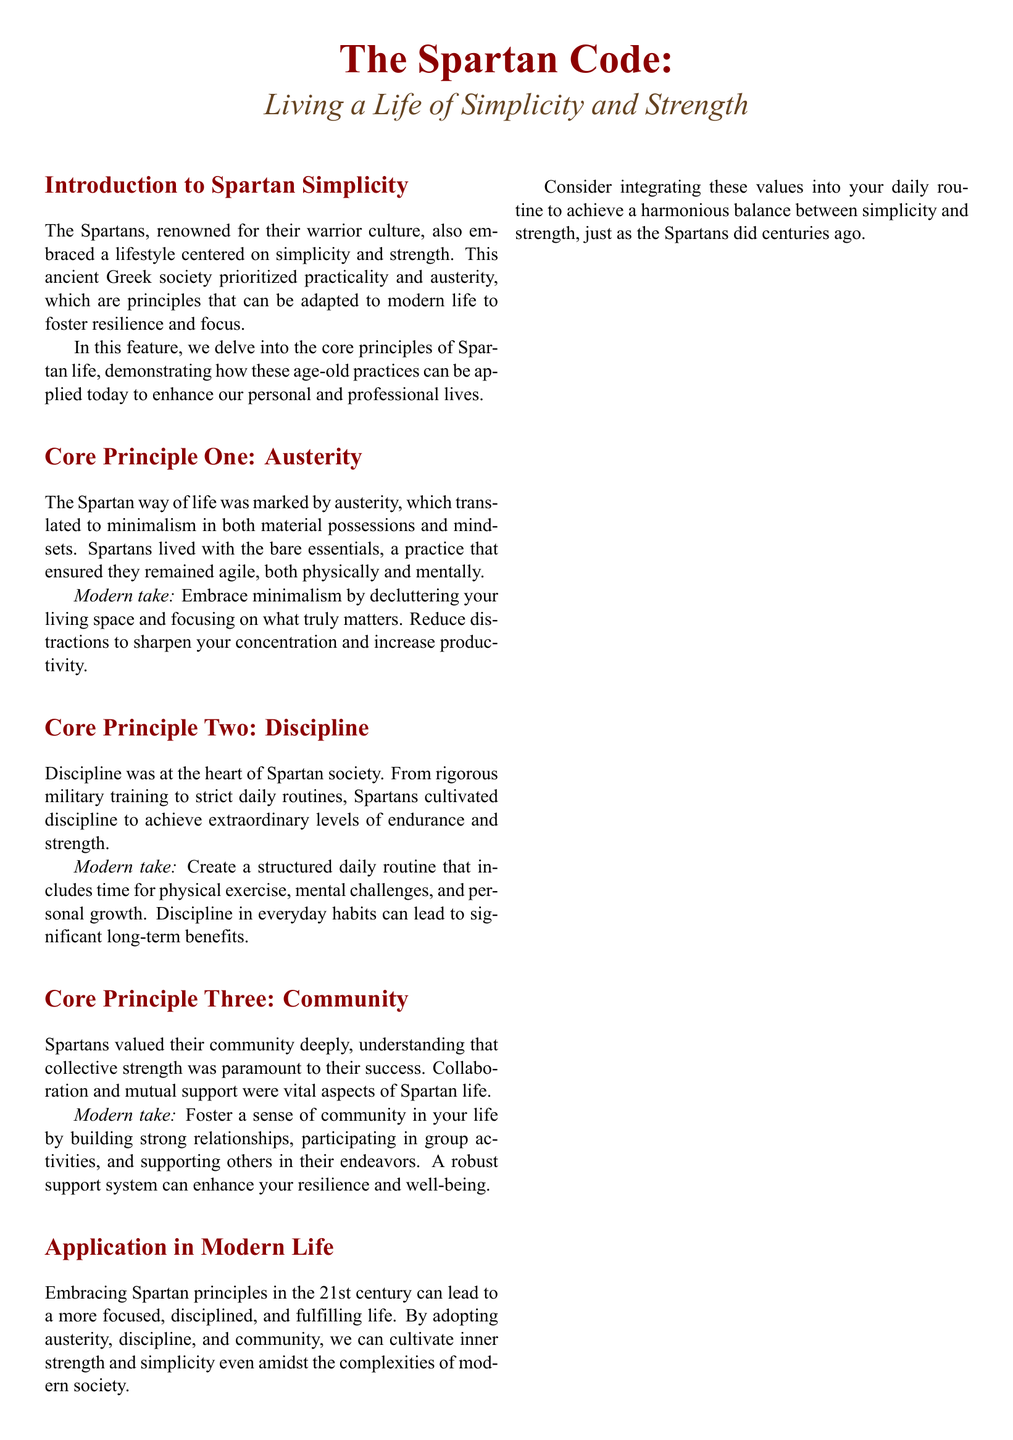What is the title of the feature? The title is explicitly stated at the beginning of the document, highlighting the main topic.
Answer: The Spartan Code: Living a Life of Simplicity and Strength What core principle emphasizes minimalism? The document outlines principles, and one specifically focuses on minimalism as a way of life.
Answer: Austerity Who is quoted about discipline in the document? The document includes a quote regarding discipline attributed to a well-known figure.
Answer: Seneca How many core principles are discussed? The document lists the core principles and explicitly states their count within the text.
Answer: Three What activity does the modern take on discipline suggest to incorporate? The suggested practice in the modern context related to discipline is explicitly mentioned.
Answer: Physical exercise What color is associated with Spartan red in the document? The document provides color specifications using RGB for Spartan red.
Answer: RGB (140,0,0) What does the Spartan wisdom box contain? The document includes quotes in a specific section, described as Spartan wisdom.
Answer: Quotes What sophisticated quality is highlighted as vital in Spartan life? The document discusses the importance of a specific collective aspect related to community life.
Answer: Collaboration 